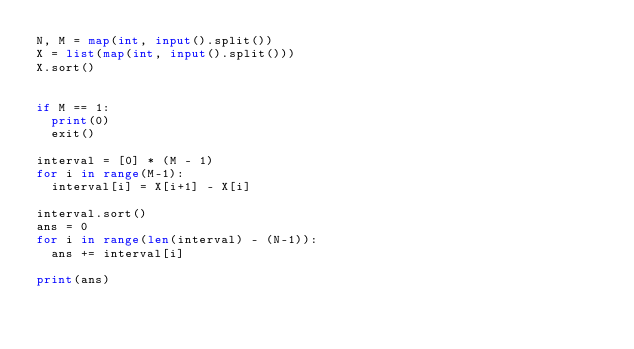Convert code to text. <code><loc_0><loc_0><loc_500><loc_500><_Python_>N, M = map(int, input().split())
X = list(map(int, input().split()))
X.sort()


if M == 1:
  print(0)
  exit()

interval = [0] * (M - 1)
for i in range(M-1):
  interval[i] = X[i+1] - X[i]
  
interval.sort()
ans = 0
for i in range(len(interval) - (N-1)):
  ans += interval[i]
  
print(ans)</code> 